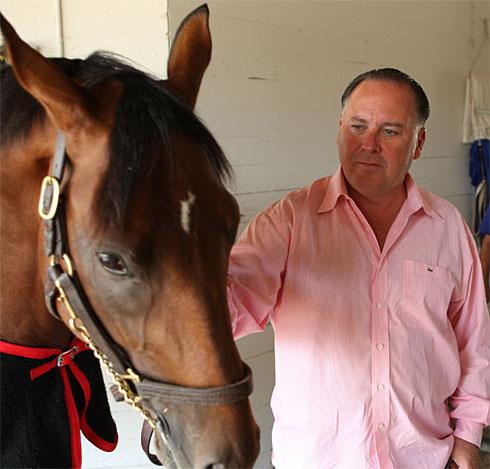What kind of animal is this?
Keep it brief. Horse. What is the man doing to the horses mane?
Give a very brief answer. Petting. What color is the man's shirt?
Answer briefly. Pink. What is this man doing to the horse?
Answer briefly. Petting. What is the name of the photo?
Give a very brief answer. Horse and man. What color is the horse?
Give a very brief answer. Brown. What animal is he petting?
Short answer required. Horse. How many people's faces do you see?
Quick response, please. 1. What is on the man's face?
Answer briefly. Nothing. 